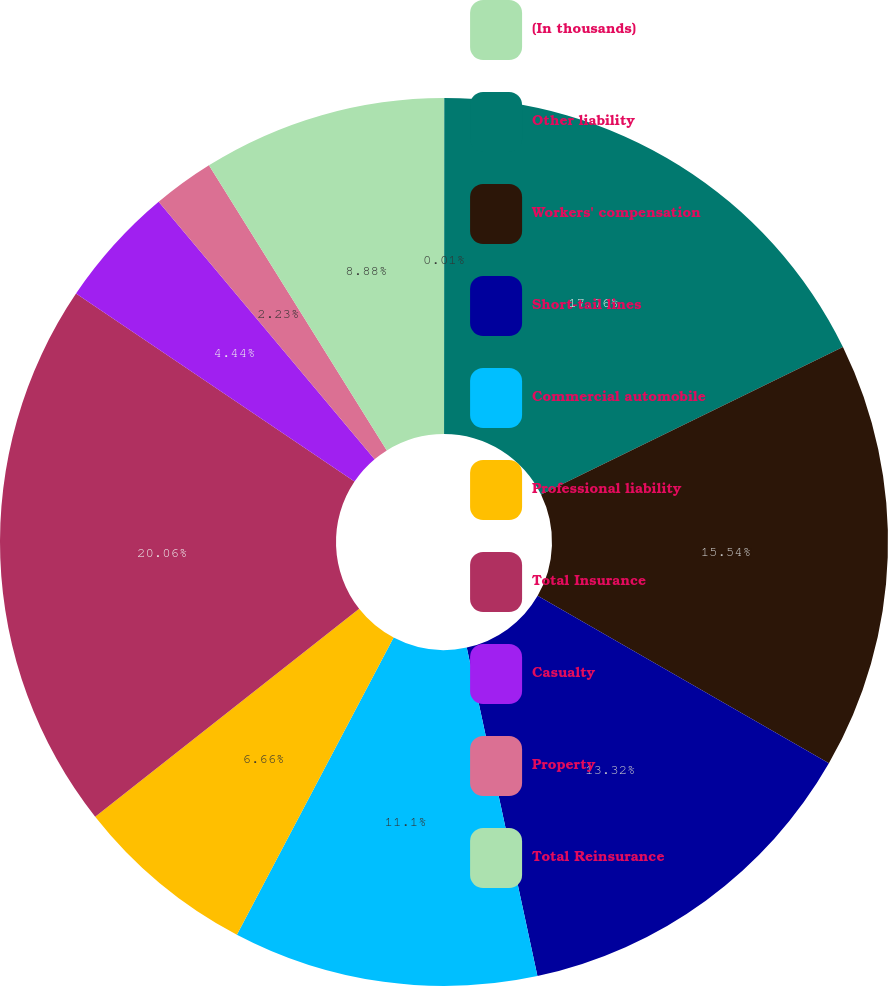<chart> <loc_0><loc_0><loc_500><loc_500><pie_chart><fcel>(In thousands)<fcel>Other liability<fcel>Workers' compensation<fcel>Short-tail lines<fcel>Commercial automobile<fcel>Professional liability<fcel>Total Insurance<fcel>Casualty<fcel>Property<fcel>Total Reinsurance<nl><fcel>0.01%<fcel>17.76%<fcel>15.54%<fcel>13.32%<fcel>11.1%<fcel>6.66%<fcel>20.07%<fcel>4.44%<fcel>2.23%<fcel>8.88%<nl></chart> 